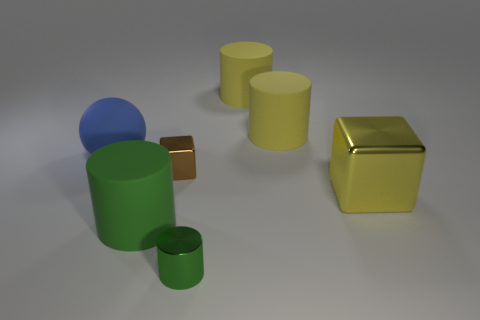What time of day does the lighting suggest? The lighting in the image is soft and diffuse, lacking strong shadows or highlights. This suggests an indoor setting with controlled lighting rather than a specific time of day. Are there any sources of light visible in the image? No direct light sources are visible in the image. The lighting appears to be coming from above, outside of the frame, which evenly illuminates the objects without casting harsh shadows. 